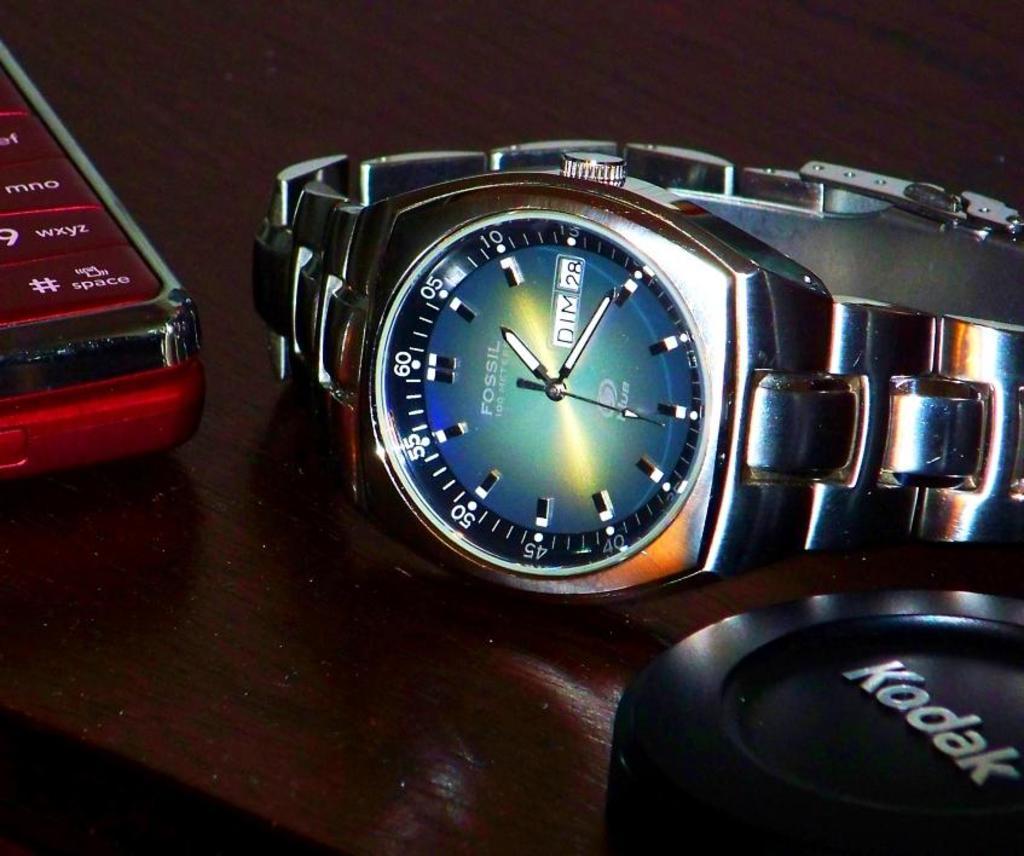Is this a fossil watch?
Offer a very short reply. Yes. Is the brand kodak mentioned?
Provide a succinct answer. Yes. 